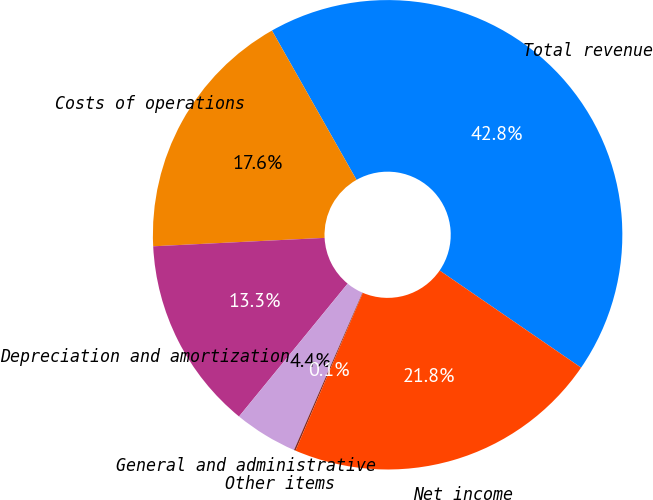Convert chart. <chart><loc_0><loc_0><loc_500><loc_500><pie_chart><fcel>Total revenue<fcel>Costs of operations<fcel>Depreciation and amortization<fcel>General and administrative<fcel>Other items<fcel>Net income<nl><fcel>42.78%<fcel>17.58%<fcel>13.31%<fcel>4.38%<fcel>0.11%<fcel>21.84%<nl></chart> 